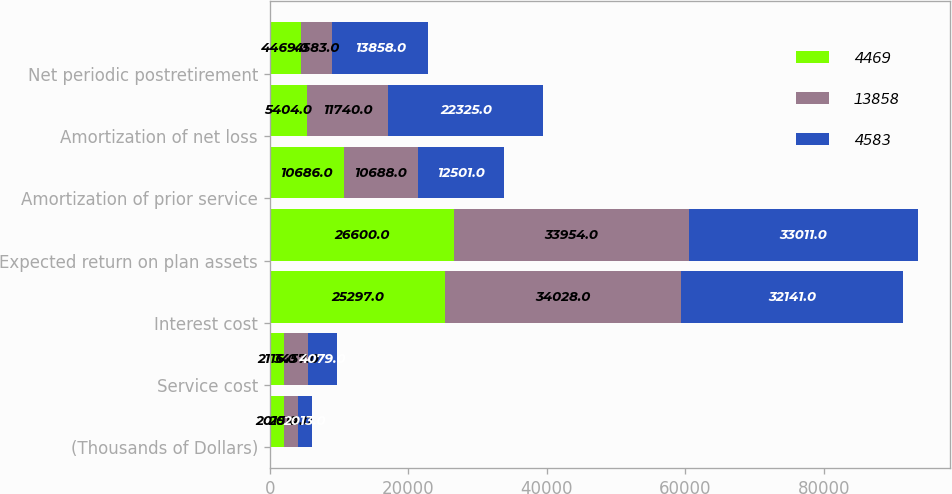Convert chart to OTSL. <chart><loc_0><loc_0><loc_500><loc_500><stacked_bar_chart><ecel><fcel>(Thousands of Dollars)<fcel>Service cost<fcel>Interest cost<fcel>Expected return on plan assets<fcel>Amortization of prior service<fcel>Amortization of net loss<fcel>Net periodic postretirement<nl><fcel>4469<fcel>2015<fcel>2116<fcel>25297<fcel>26600<fcel>10686<fcel>5404<fcel>4469<nl><fcel>13858<fcel>2014<fcel>3457<fcel>34028<fcel>33954<fcel>10688<fcel>11740<fcel>4583<nl><fcel>4583<fcel>2013<fcel>4079<fcel>32141<fcel>33011<fcel>12501<fcel>22325<fcel>13858<nl></chart> 